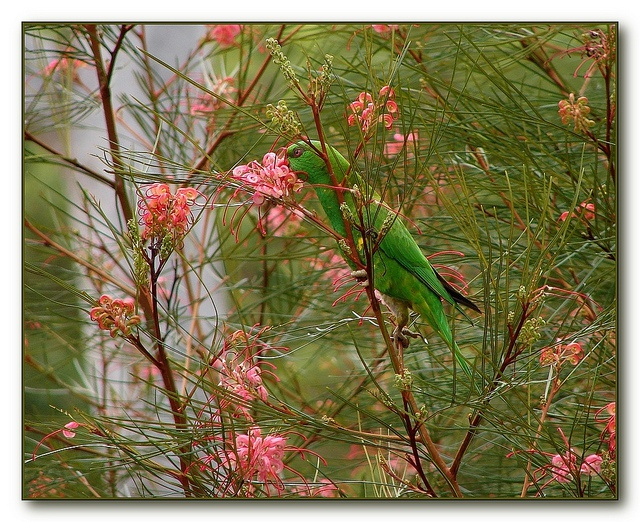Describe the objects in this image and their specific colors. I can see a bird in white, darkgreen, black, and green tones in this image. 